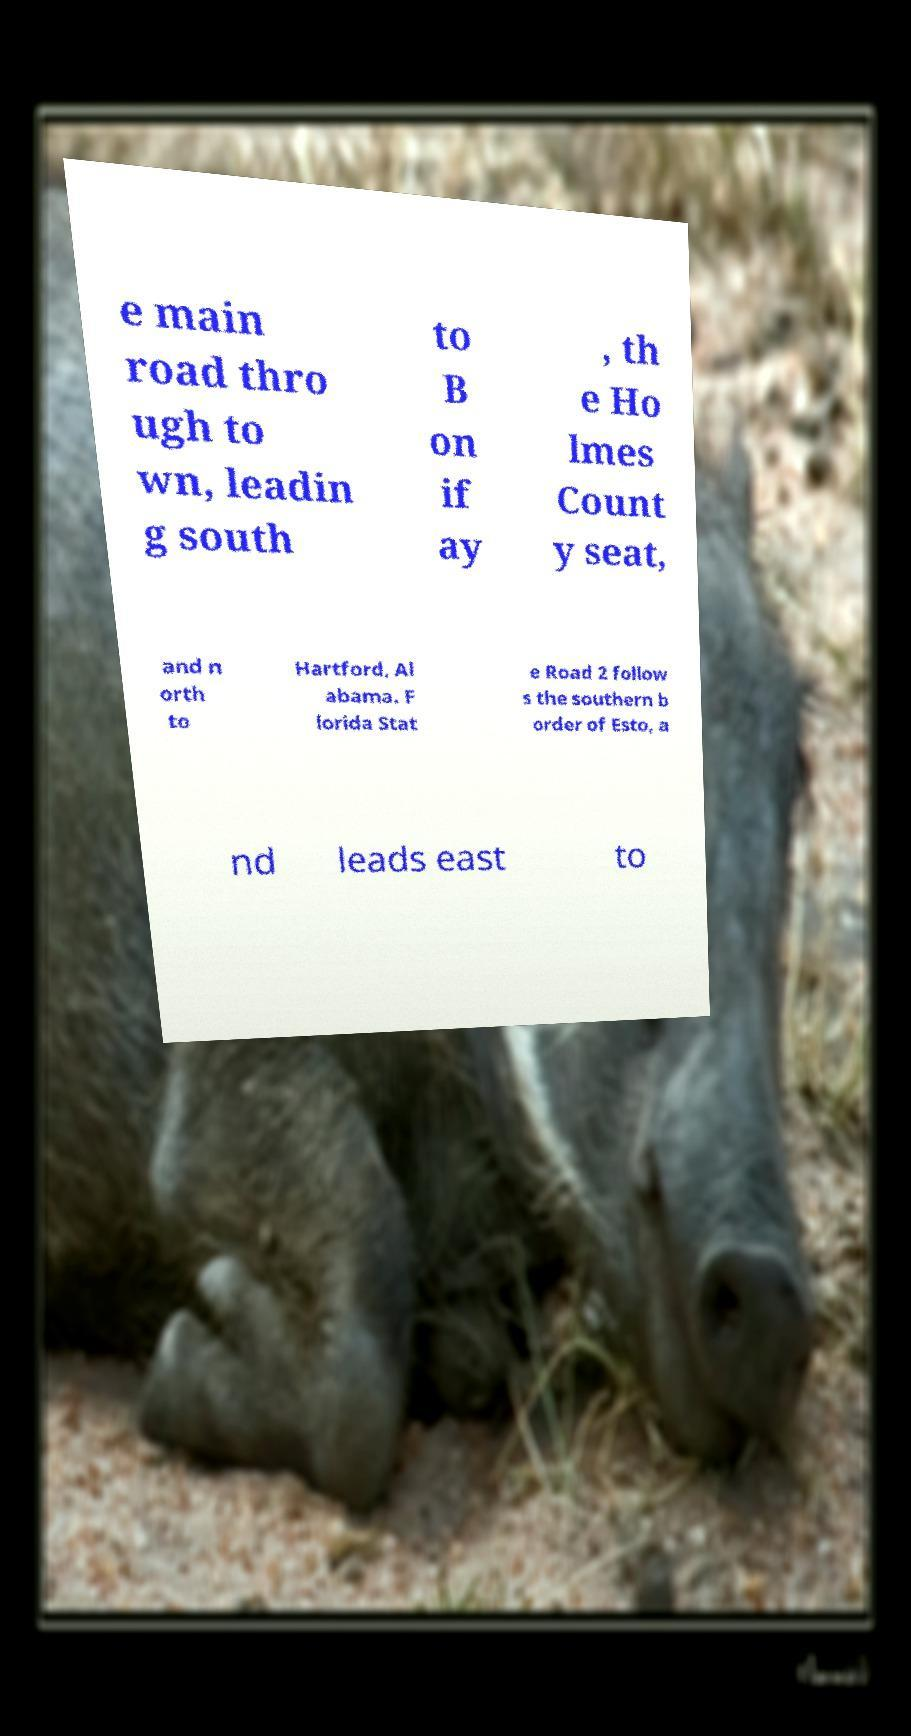There's text embedded in this image that I need extracted. Can you transcribe it verbatim? e main road thro ugh to wn, leadin g south to B on if ay , th e Ho lmes Count y seat, and n orth to Hartford, Al abama. F lorida Stat e Road 2 follow s the southern b order of Esto, a nd leads east to 